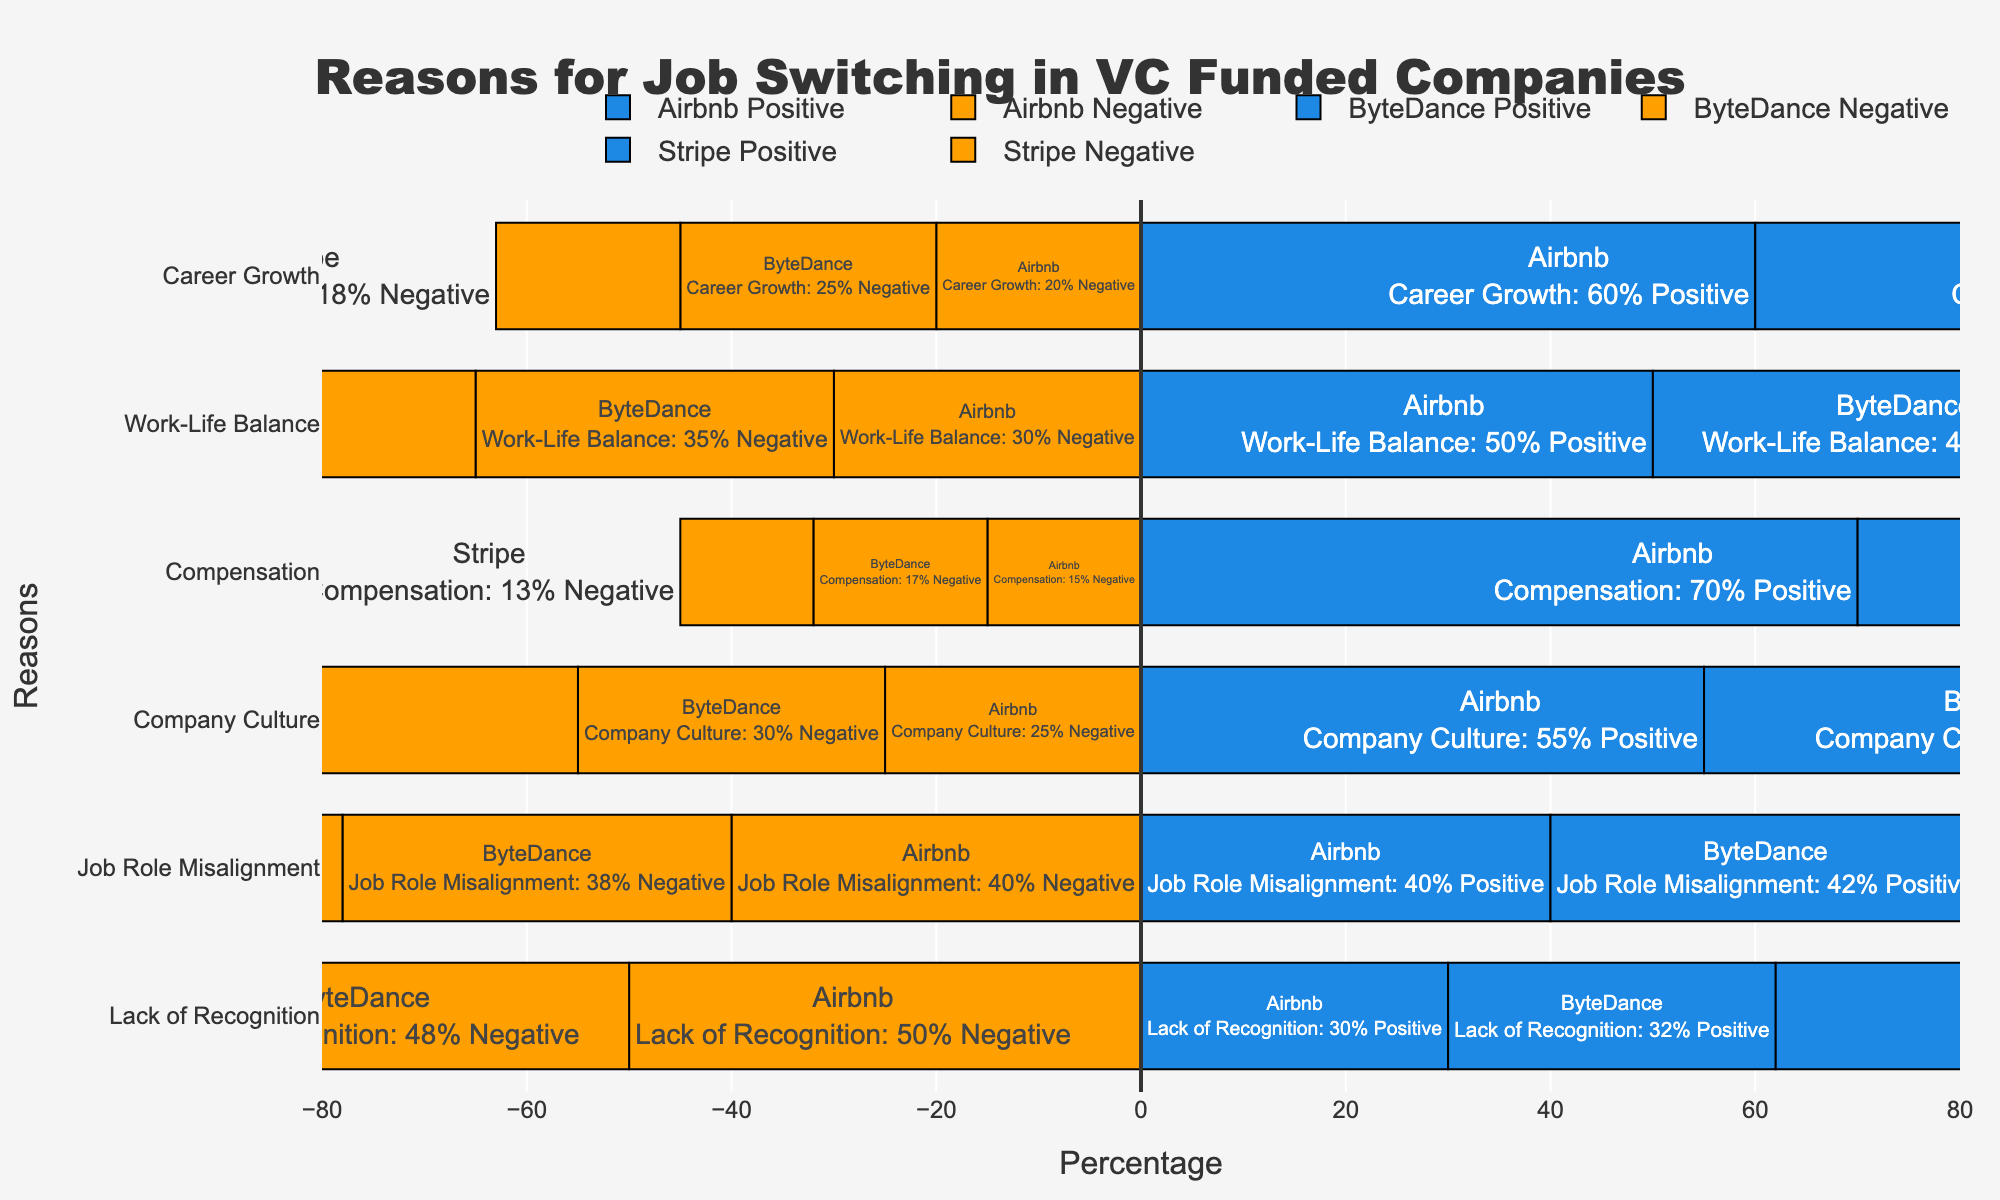Which company has the highest percentage of positive responses for Compensation? Look at the bars representing positive percentages for Compensation across all companies. The highest positive bar corresponds to Stripe with 72%.
Answer: Stripe Which company has the lowest negative response percentage for Work-Life Balance? Look at the bars representing negative percentages for Work-Life Balance across all companies. The smallest negative bar belongs to ByteDance with 35%.
Answer: ByteDance How much higher is the percentage of positive responses for Career Growth at Airbnb compared to ByteDance? Airbnb has a positive percentage of 60% for Career Growth, while ByteDance has 55%. The difference is 60% - 55% = 5%.
Answer: 5% What is the total percentage of neutral responses for Company Culture across all companies? The neutral percentage for Company Culture is 20% for Airbnb, 20% for ByteDance, and 20% for Stripe. The total is 20 + 20 + 20 = 60%.
Answer: 60% Which reason for job switching has the highest percentage of negative responses at ByteDance? Examine the negative bars for ByteDance across all reasons for job switching. Lack of Recognition has the highest negative response with 48%.
Answer: Lack of Recognition Compare the positive response percentages for Job Role Misalignment at Stripe and Airbnb; which one is higher? Stripe has a positive percentage of 45% for Job Role Misalignment, while Airbnb has 40%. Thus, Stripe is higher.
Answer: Stripe What is the average percentage of positive responses for Company Culture among all three companies? Calculate the average of the positive percentages for Company Culture among Airbnb (55%), ByteDance (50%), and Stripe (53%). (55 + 50 + 53) / 3 = 52.67%.
Answer: 52.67% Identify the company with the smallest difference between positive and negative responses for Career Growth. Calculate the differences for Career Growth: Airbnb (60 - 20 = 40), ByteDance (55 - 25 = 30), Stripe (62 - 18 = 44). ByteDance has the smallest difference with 30%.
Answer: ByteDance What is the combined percentage of negative responses for Job Role Misalignment at all companies? Sum the negative responses for Job Role Misalignment: Airbnb (40%), ByteDance (38%), and Stripe (35%). The combined total is 40 + 38 + 35 = 113%.
Answer: 113% 